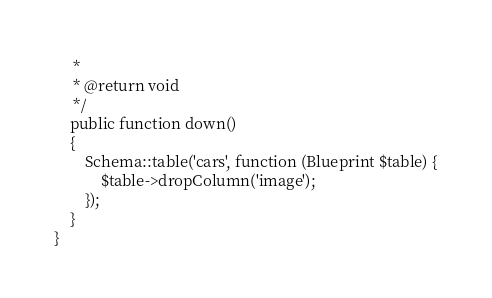<code> <loc_0><loc_0><loc_500><loc_500><_PHP_>     *
     * @return void
     */
    public function down()
    {
        Schema::table('cars', function (Blueprint $table) {
            $table->dropColumn('image');
        });
    }
}
</code> 